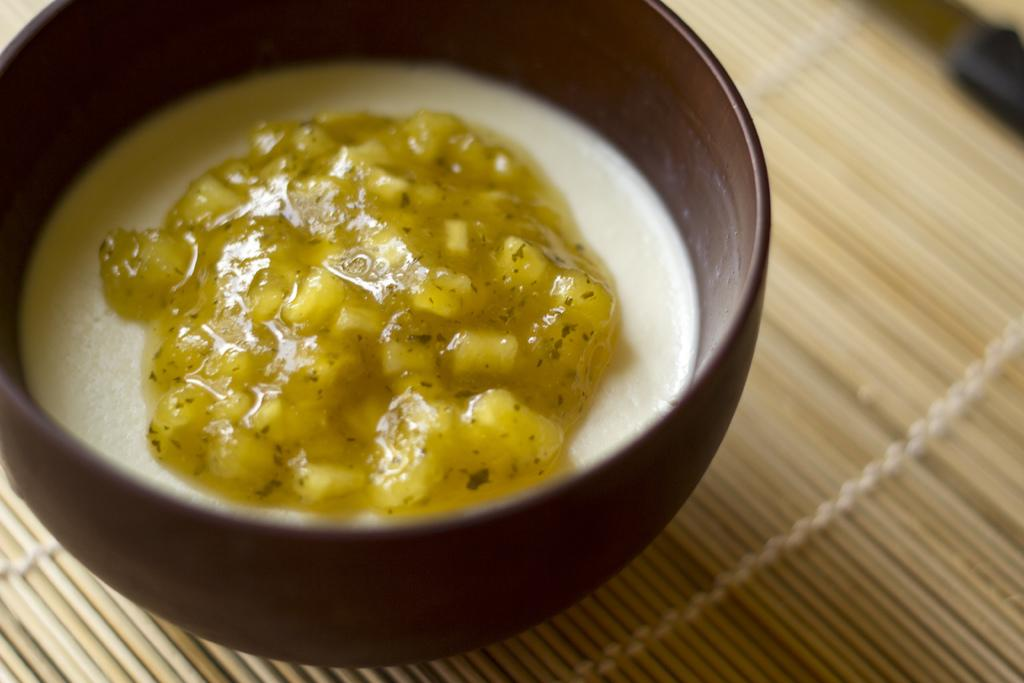What color is the bowl in the image? The bowl in the image is brown-colored. What is inside the bowl? The bowl contains yellow and white objects. What is the color of the surface under the bowl? The surface under the bowl is cream-colored. How many bikes are parked next to the bowl in the image? There are no bikes present in the image. What type of answer is provided in the image? There is no answer provided in the image, as it is a still image and not a conversation or text. 